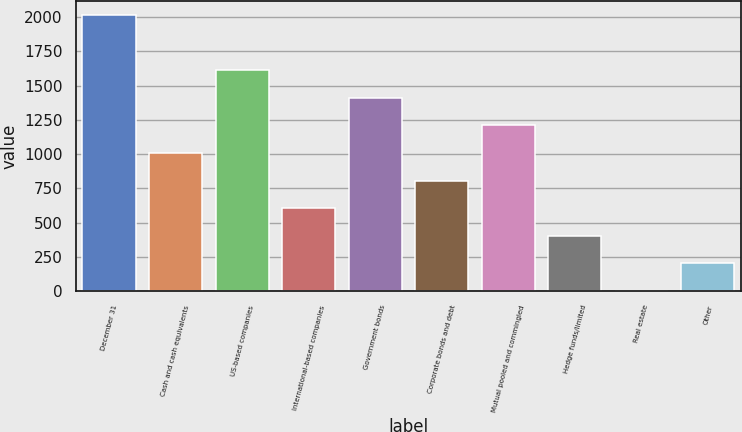Convert chart. <chart><loc_0><loc_0><loc_500><loc_500><bar_chart><fcel>December 31<fcel>Cash and cash equivalents<fcel>US-based companies<fcel>International-based companies<fcel>Government bonds<fcel>Corporate bonds and debt<fcel>Mutual pooled and commingled<fcel>Hedge funds/limited<fcel>Real estate<fcel>Other<nl><fcel>2014<fcel>1008.5<fcel>1611.8<fcel>606.3<fcel>1410.7<fcel>807.4<fcel>1209.6<fcel>405.2<fcel>3<fcel>204.1<nl></chart> 